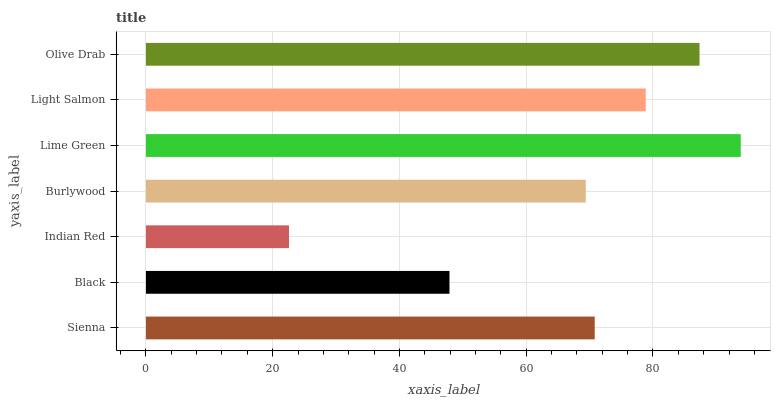Is Indian Red the minimum?
Answer yes or no. Yes. Is Lime Green the maximum?
Answer yes or no. Yes. Is Black the minimum?
Answer yes or no. No. Is Black the maximum?
Answer yes or no. No. Is Sienna greater than Black?
Answer yes or no. Yes. Is Black less than Sienna?
Answer yes or no. Yes. Is Black greater than Sienna?
Answer yes or no. No. Is Sienna less than Black?
Answer yes or no. No. Is Sienna the high median?
Answer yes or no. Yes. Is Sienna the low median?
Answer yes or no. Yes. Is Light Salmon the high median?
Answer yes or no. No. Is Lime Green the low median?
Answer yes or no. No. 